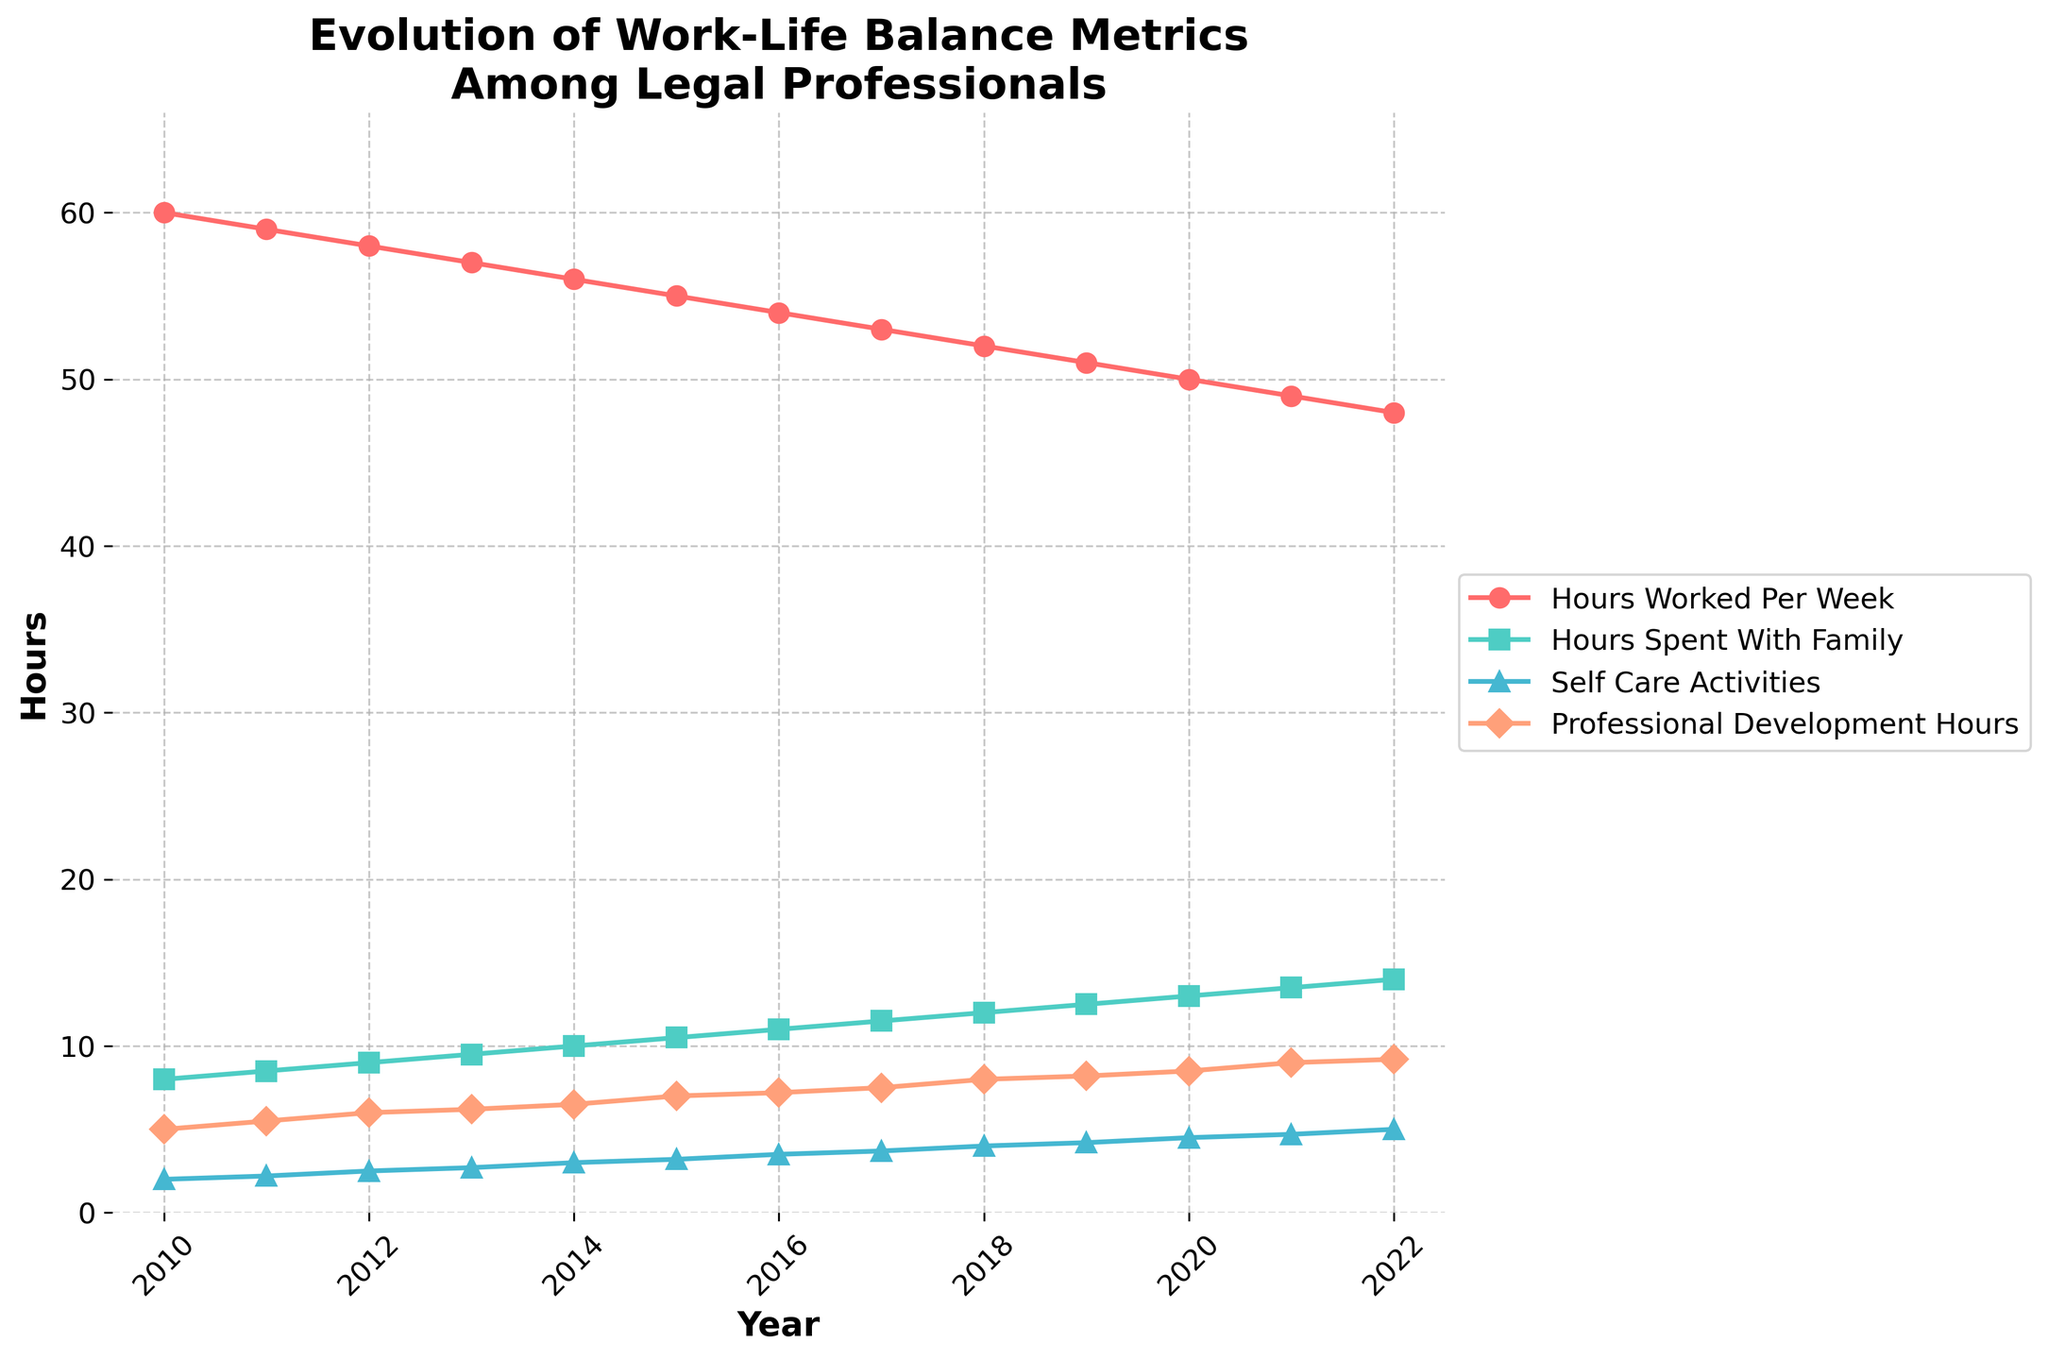How many different work-life balance metrics are tracked in the figure? The figure shows four different lines, each representing a work-life balance metric. These metrics are titles next to the points and in the legend.
Answer: 4 What is the general trend of the 'Hours Worked Per Week' from 2010 to 2022? By looking at the 'Hours Worked Per Week' line in the figure over the 12-year period, it consistently decreases from around 60 hours in 2010 to 48 hours in 2022.
Answer: Decreasing Which metric has the highest value in the year 2010? The lines and markers in the figure indicate that 'Hours Worked Per Week' has the highest value in 2010 compared to other metrics.
Answer: Hours Worked Per Week What is the title of the figure? The title is displayed at the top of the figure.
Answer: Evolution of Work-Life Balance Metrics Among Legal Professionals How many data points are there for each metric? Referring to the x-axis and the consistent yearly data points from 2010 to 2022, there are 13 data points for each metric.
Answer: 13 Which metric showed the greatest increase from 2010 to 2022? By comparing the initial and final values of each metric, 'Hours Spent With Family' increased from 8 hours in 2010 to 14 hours in 2022, the largest change among the metrics.
Answer: Hours Spent With Family In what year did 'Hours Spent With Family' exceed 'Hours Worked Per Week' by at least 1 hour? By closely observing the lines, in 2022, 'Hours Spent With Family' (14 hours) exceeds 'Hours Worked Per Week' (48 hours) by 6 hours.
Answer: 2022 Which metric had the least variation over the years? Looking at the lines, 'Self-Care Activities' appears the flattest, indicating the least variation, rising only from 2 to 5 hours over the years.
Answer: Self-Care Activities What is the average 'Professional Development Hours' in 2010 and 2022? Combining the values of 'Professional Development Hours' in 2010 and 2022 (5 and 9.2), and then dividing by 2 gives the average.
Answer: 7.1 